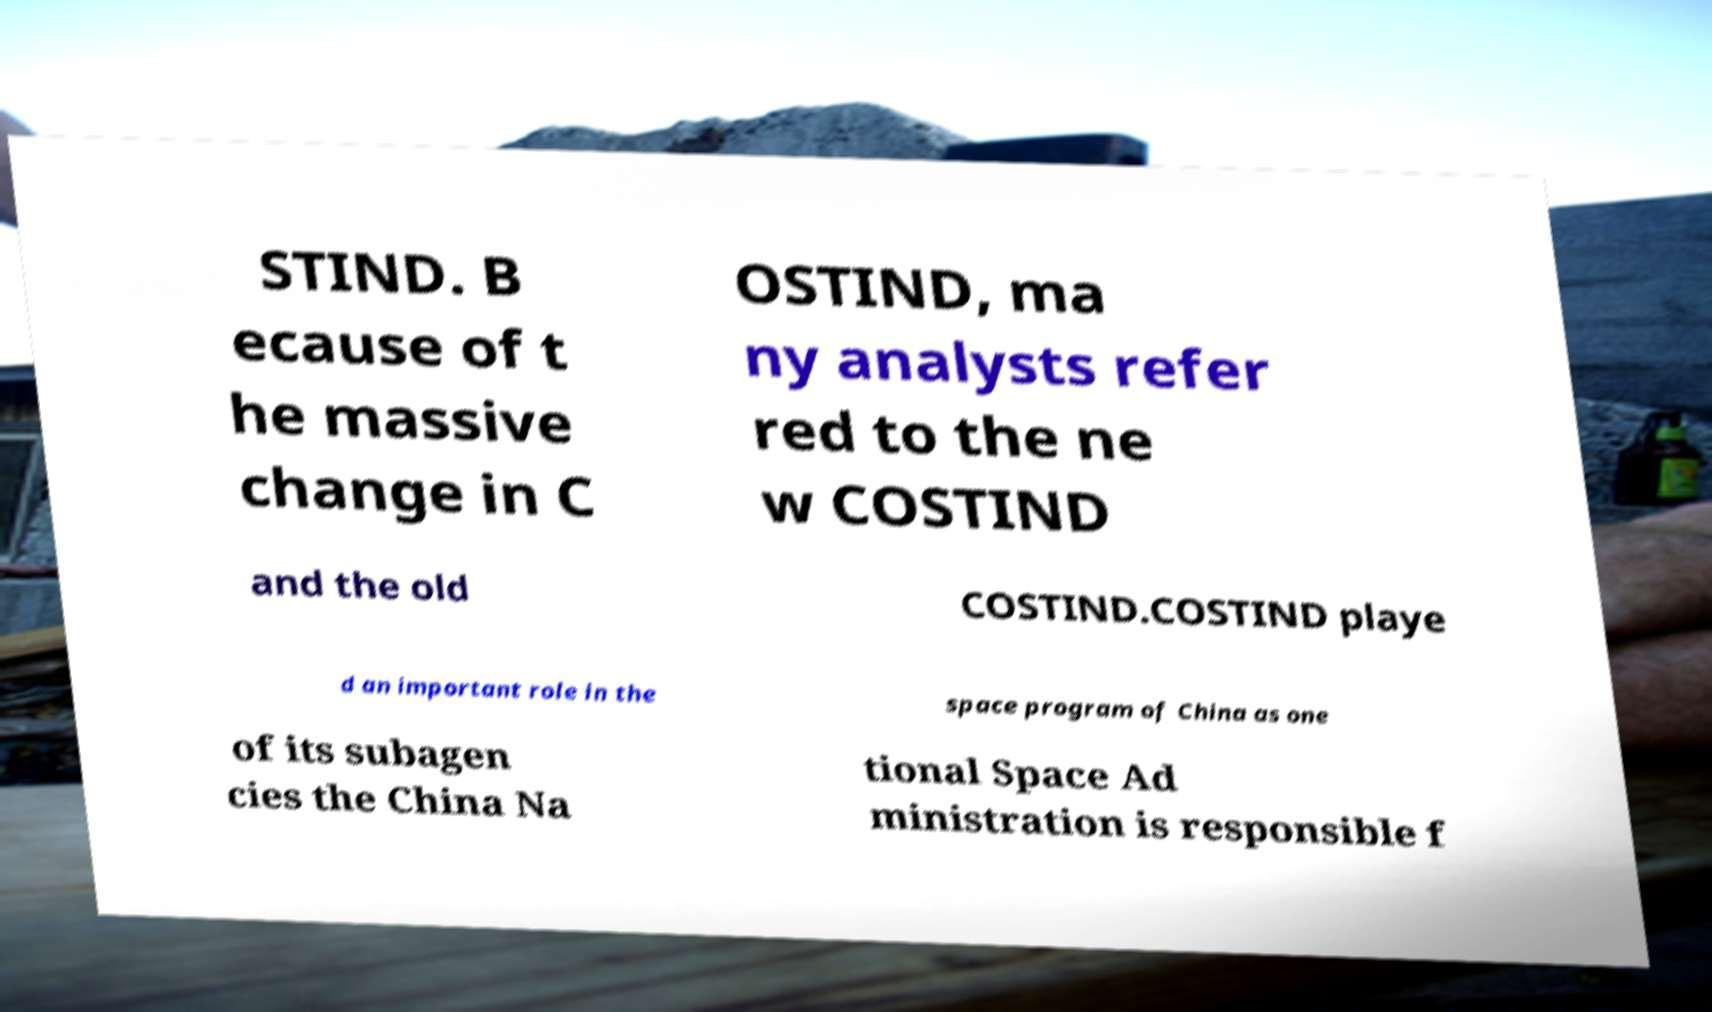What messages or text are displayed in this image? I need them in a readable, typed format. STIND. B ecause of t he massive change in C OSTIND, ma ny analysts refer red to the ne w COSTIND and the old COSTIND.COSTIND playe d an important role in the space program of China as one of its subagen cies the China Na tional Space Ad ministration is responsible f 